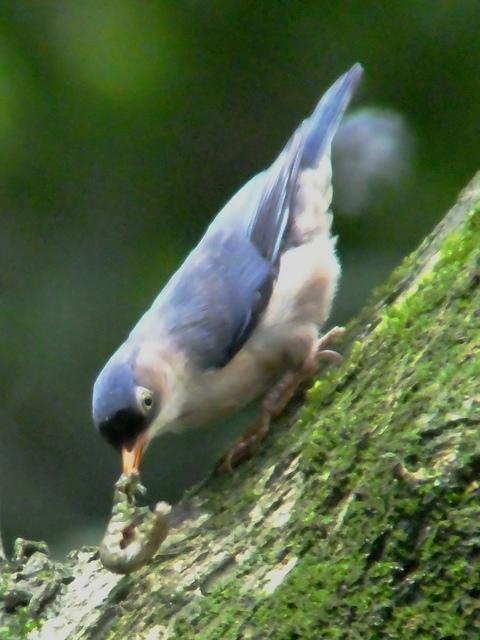What are green?
Answer briefly. Moss. What is the bird doing?
Write a very short answer. Eating. Is this bird eating?
Quick response, please. Yes. 